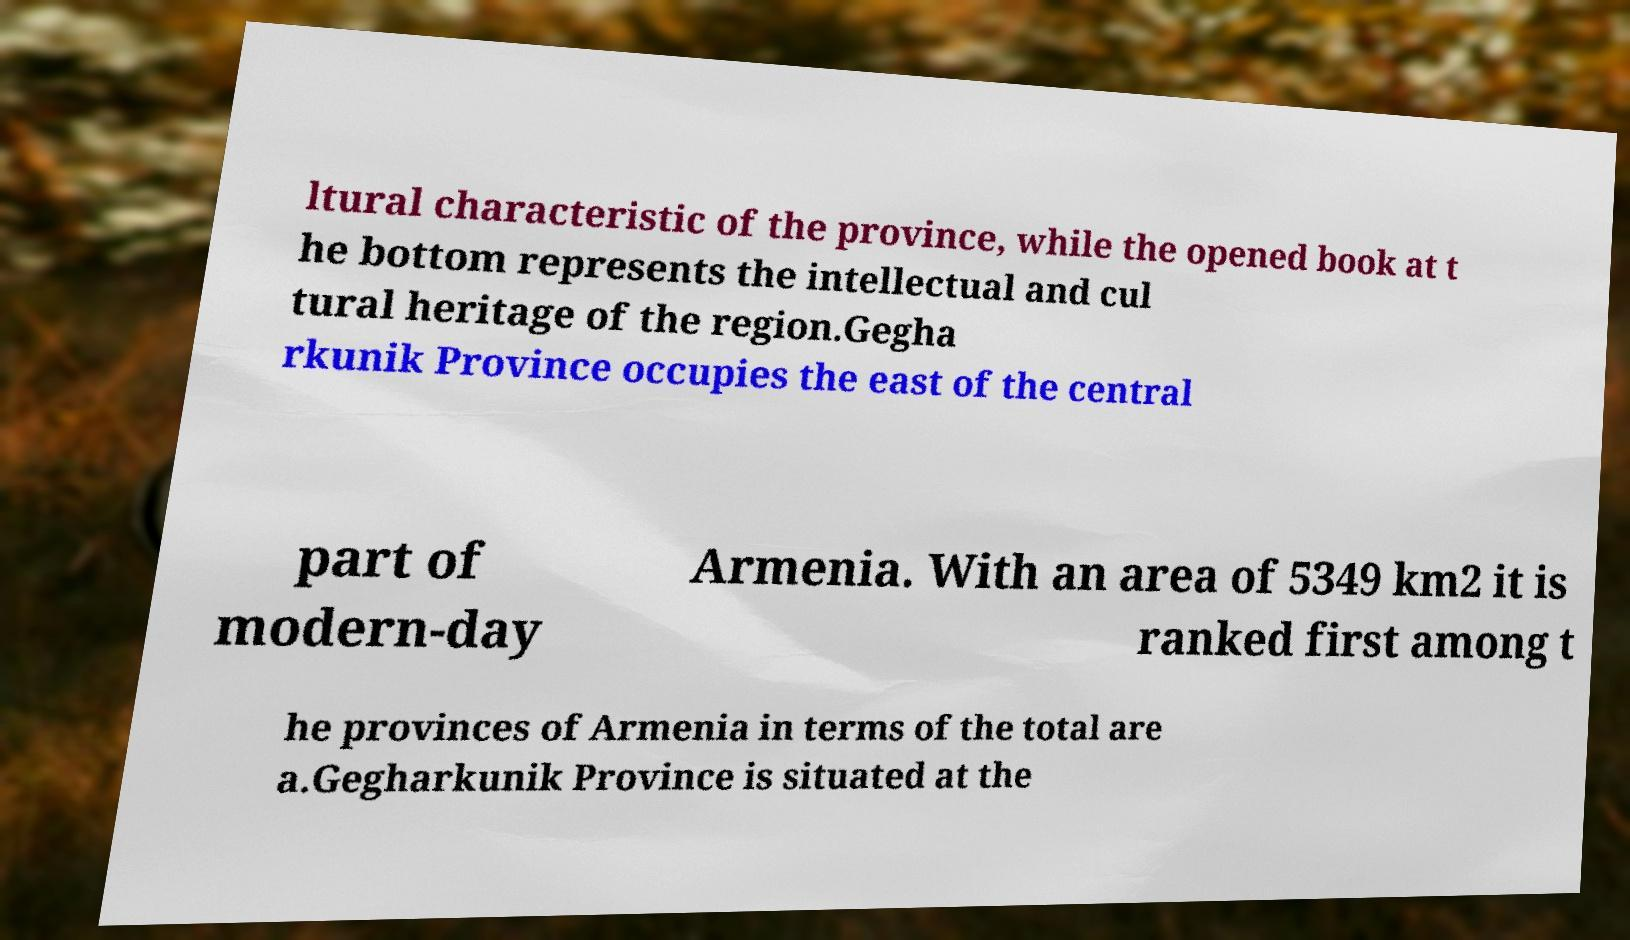Can you read and provide the text displayed in the image?This photo seems to have some interesting text. Can you extract and type it out for me? ltural characteristic of the province, while the opened book at t he bottom represents the intellectual and cul tural heritage of the region.Gegha rkunik Province occupies the east of the central part of modern-day Armenia. With an area of 5349 km2 it is ranked first among t he provinces of Armenia in terms of the total are a.Gegharkunik Province is situated at the 